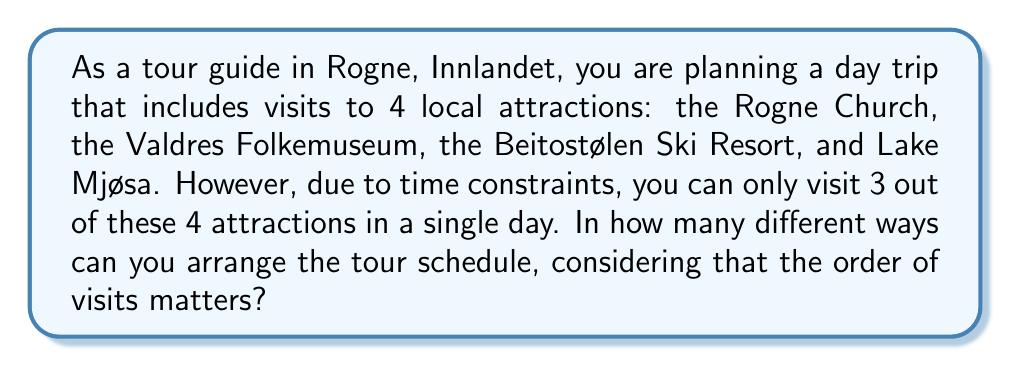Provide a solution to this math problem. To solve this problem, we need to use the concept of permutations from abstract algebra. Here's how we can approach it:

1) First, we need to select 3 attractions out of 4. This is a combination problem, denoted as $\binom{4}{3}$.

   $\binom{4}{3} = \frac{4!}{3!(4-3)!} = \frac{4!}{3!1!} = 4$

2) For each of these 4 combinations, we need to consider all possible orderings. This is where permutations come in. We are arranging 3 attractions, so this is a permutation of 3 elements, denoted as $P(3)$ or $3!$.

   $3! = 3 \times 2 \times 1 = 6$

3) By the multiplication principle, the total number of unique tour schedules is the product of the number of ways to choose 3 attractions and the number of ways to order them:

   $\text{Total schedules} = \binom{4}{3} \times 3!$

4) Calculating:
   
   $\text{Total schedules} = 4 \times 6 = 24$

From the perspective of permutation groups, we can think of this as the order of the symmetric group $S_3$ (which represents all possible orderings of 3 elements) multiplied by the number of ways to choose 3 elements from 4.
Answer: There are 24 different ways to arrange the tour schedule. 